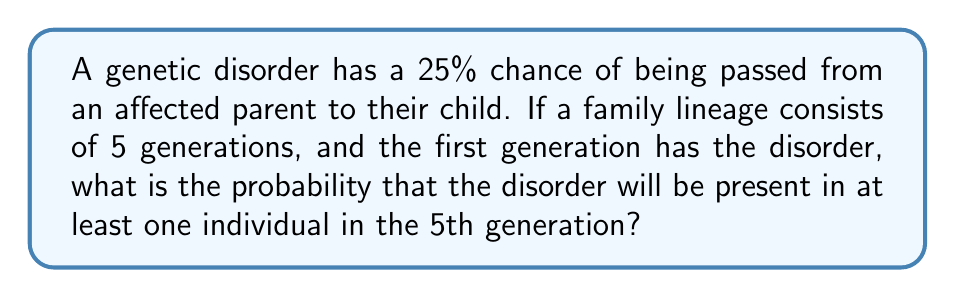Show me your answer to this math problem. Let's approach this step-by-step:

1) First, let's calculate the probability that the disorder is NOT passed to a child:
   $P(\text{not passed}) = 1 - 0.25 = 0.75$ or 75%

2) For the disorder to reach the 5th generation, it must be passed through each of the 4 intermediary generations. The probability of it NOT being passed through all 4 generations is:
   $P(\text{not passed through 4 generations}) = 0.75^4 \approx 0.3164$ or 31.64%

3) Therefore, the probability that the disorder IS passed through all 4 generations to at least one person in the 5th generation is:
   $P(\text{passed to 5th generation}) = 1 - 0.3164 = 0.6836$ or 68.36%

4) We can also express this using the geometric series formula:
   $$S_n = a\frac{1-r^n}{1-r}$$
   Where $a = 1$ (initial probability), $r = 0.75$ (common ratio), and $n = 4$ (number of generations between 1st and 5th)

   $$S_4 = 1\frac{1-0.75^4}{1-0.75} = 1\frac{1-0.3164}{0.25} = 0.6836$$

This confirms our previous calculation.
Answer: 68.36% 